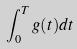<formula> <loc_0><loc_0><loc_500><loc_500>\int _ { 0 } ^ { T } g ( t ) d t</formula> 